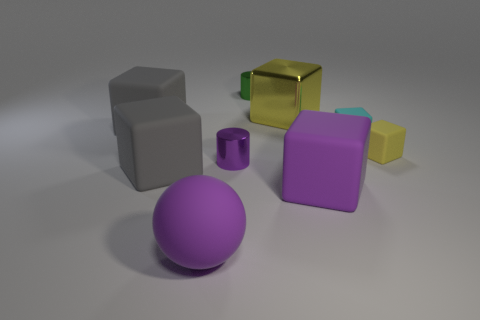Subtract all tiny blocks. How many blocks are left? 4 Subtract all cyan cylinders. How many yellow cubes are left? 2 Subtract 3 blocks. How many blocks are left? 3 Subtract all purple cubes. How many cubes are left? 5 Subtract all cylinders. How many objects are left? 7 Add 5 tiny green cylinders. How many tiny green cylinders are left? 6 Add 2 tiny cylinders. How many tiny cylinders exist? 4 Subtract 1 cyan cubes. How many objects are left? 8 Subtract all yellow blocks. Subtract all cyan balls. How many blocks are left? 4 Subtract all large spheres. Subtract all matte blocks. How many objects are left? 3 